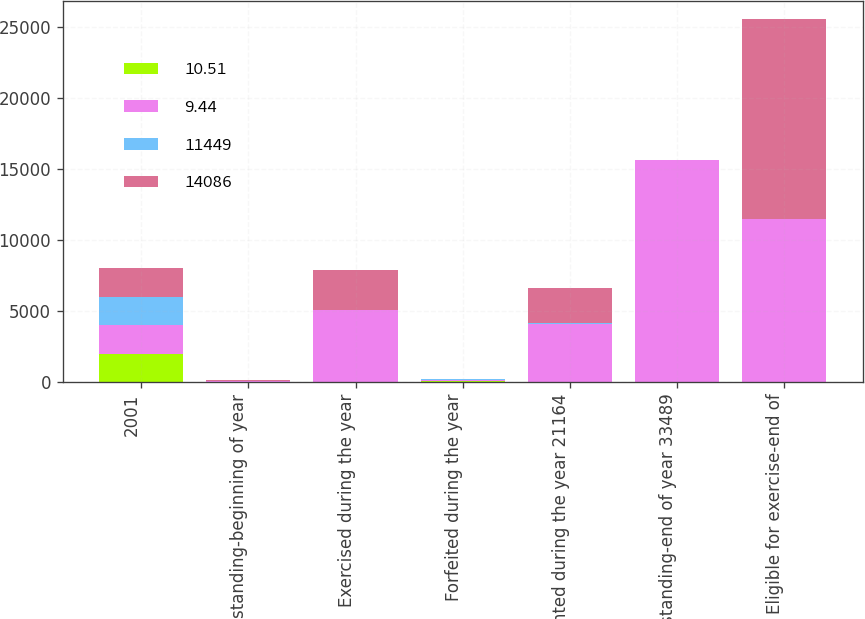<chart> <loc_0><loc_0><loc_500><loc_500><stacked_bar_chart><ecel><fcel>2001<fcel>Outstanding-beginning of year<fcel>Exercised during the year<fcel>Forfeited during the year<fcel>Granted during the year 21164<fcel>Outstanding-end of year 33489<fcel>Eligible for exercise-end of<nl><fcel>10.51<fcel>2001<fcel>16.32<fcel>8.95<fcel>42.21<fcel>17.78<fcel>16.55<fcel>13.38<nl><fcel>9.44<fcel>2000<fcel>42.21<fcel>5069<fcel>129<fcel>4075<fcel>15575<fcel>11449<nl><fcel>11449<fcel>2000<fcel>10.72<fcel>14.11<fcel>30.85<fcel>36.98<fcel>16.32<fcel>10.51<nl><fcel>14086<fcel>1999<fcel>42.21<fcel>2817<fcel>14<fcel>2464<fcel>42.21<fcel>14086<nl></chart> 